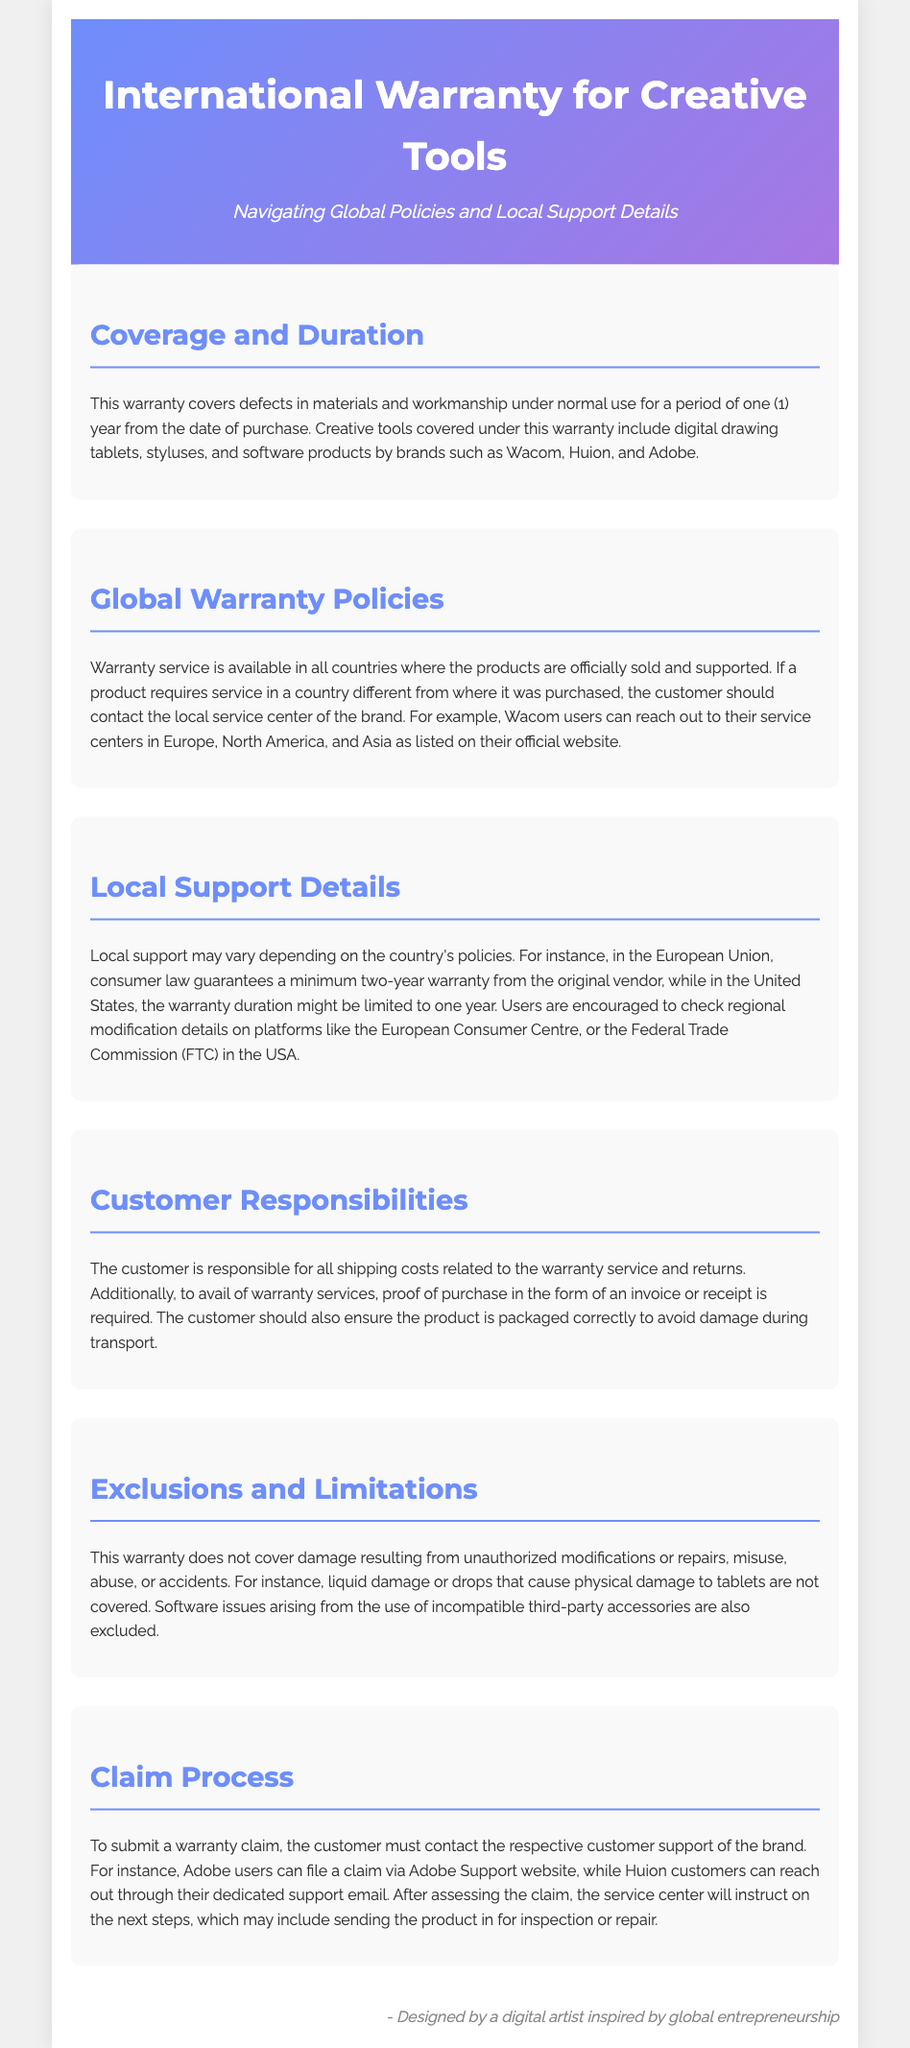What is the warranty duration for creative tools? The document states that the warranty covers defects in materials and workmanship for a period of one (1) year from the date of purchase.
Answer: one year What types of products are covered under this warranty? The warranty covers digital drawing tablets, styluses, and software products by brands such as Wacom, Huion, and Adobe.
Answer: digital drawing tablets, styluses, and software products Which regions offer warranty service for these products? The document mentions that warranty service is available in all countries where the products are officially sold and supported.
Answer: all countries What is required from the customer to avail of warranty services? The customer must provide proof of purchase in the form of an invoice or receipt.
Answer: proof of purchase What type of damage is excluded from the warranty? The document specifically excludes damage from unauthorized modifications, misuse, abuse, or accidents, such as liquid damage.
Answer: unauthorized modifications, misuse, abuse, or accidents How can a customer submit a warranty claim? The customer must contact the respective customer support of the brand to submit a warranty claim.
Answer: contact customer support What is the customer's responsibility regarding shipping costs? Customers are responsible for all shipping costs related to the warranty service and returns.
Answer: all shipping costs Does the warranty cover software issues from third-party accessories? The warranty explicitly states that software issues arising from the use of incompatible third-party accessories are excluded.
Answer: excluded 